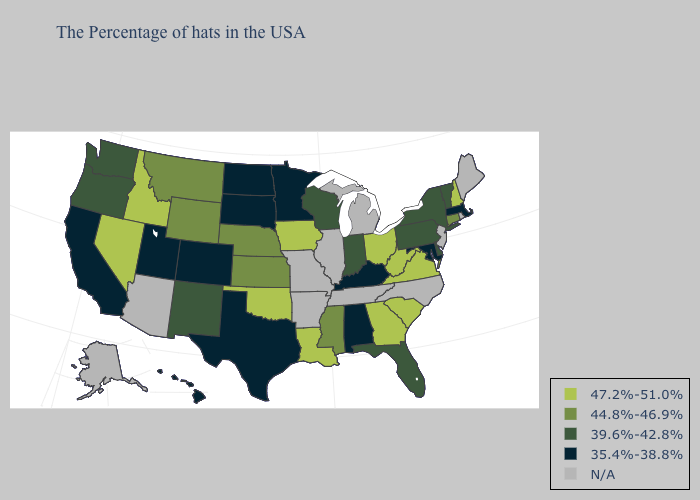What is the value of Delaware?
Short answer required. 39.6%-42.8%. What is the highest value in states that border New Jersey?
Concise answer only. 39.6%-42.8%. What is the lowest value in the Northeast?
Keep it brief. 35.4%-38.8%. Does Connecticut have the highest value in the Northeast?
Keep it brief. No. Which states have the lowest value in the USA?
Keep it brief. Massachusetts, Maryland, Kentucky, Alabama, Minnesota, Texas, South Dakota, North Dakota, Colorado, Utah, California, Hawaii. What is the value of Delaware?
Answer briefly. 39.6%-42.8%. What is the value of Indiana?
Short answer required. 39.6%-42.8%. What is the value of Montana?
Give a very brief answer. 44.8%-46.9%. Name the states that have a value in the range 47.2%-51.0%?
Quick response, please. New Hampshire, Virginia, South Carolina, West Virginia, Ohio, Georgia, Louisiana, Iowa, Oklahoma, Idaho, Nevada. Which states have the lowest value in the USA?
Short answer required. Massachusetts, Maryland, Kentucky, Alabama, Minnesota, Texas, South Dakota, North Dakota, Colorado, Utah, California, Hawaii. What is the value of Rhode Island?
Keep it brief. N/A. Does the map have missing data?
Keep it brief. Yes. Name the states that have a value in the range N/A?
Answer briefly. Maine, Rhode Island, New Jersey, North Carolina, Michigan, Tennessee, Illinois, Missouri, Arkansas, Arizona, Alaska. What is the value of Wisconsin?
Short answer required. 39.6%-42.8%. 